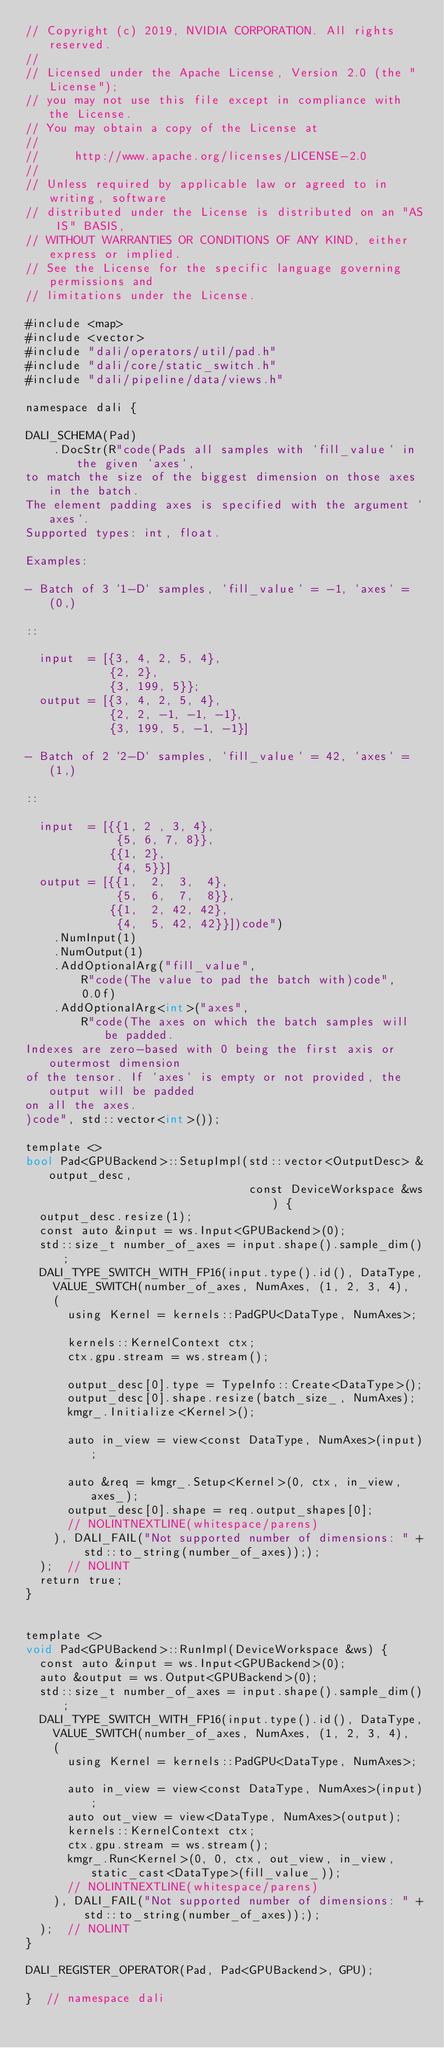<code> <loc_0><loc_0><loc_500><loc_500><_Cuda_>// Copyright (c) 2019, NVIDIA CORPORATION. All rights reserved.
//
// Licensed under the Apache License, Version 2.0 (the "License");
// you may not use this file except in compliance with the License.
// You may obtain a copy of the License at
//
//     http://www.apache.org/licenses/LICENSE-2.0
//
// Unless required by applicable law or agreed to in writing, software
// distributed under the License is distributed on an "AS IS" BASIS,
// WITHOUT WARRANTIES OR CONDITIONS OF ANY KIND, either express or implied.
// See the License for the specific language governing permissions and
// limitations under the License.

#include <map>
#include <vector>
#include "dali/operators/util/pad.h"
#include "dali/core/static_switch.h"
#include "dali/pipeline/data/views.h"

namespace dali {

DALI_SCHEMA(Pad)
    .DocStr(R"code(Pads all samples with `fill_value` in the given `axes`,
to match the size of the biggest dimension on those axes in the batch.
The element padding axes is specified with the argument `axes`.
Supported types: int, float.

Examples:

- Batch of 3 `1-D` samples, `fill_value` = -1, `axes` = (0,)

::

  input  = [{3, 4, 2, 5, 4},
            {2, 2},
            {3, 199, 5}};
  output = [{3, 4, 2, 5, 4},
            {2, 2, -1, -1, -1},
            {3, 199, 5, -1, -1}]

- Batch of 2 `2-D` samples, `fill_value` = 42, `axes` = (1,)

::

  input  = [{{1, 2 , 3, 4},
             {5, 6, 7, 8}},
            {{1, 2},
             {4, 5}}]
  output = [{{1,  2,  3,  4},
             {5,  6,  7,  8}},
            {{1,  2, 42, 42},
             {4,  5, 42, 42}}])code")
    .NumInput(1)
    .NumOutput(1)
    .AddOptionalArg("fill_value",
        R"code(The value to pad the batch with)code",
        0.0f)
    .AddOptionalArg<int>("axes",
        R"code(The axes on which the batch samples will be padded.
Indexes are zero-based with 0 being the first axis or outermost dimension
of the tensor. If `axes` is empty or not provided, the output will be padded
on all the axes.
)code", std::vector<int>());

template <>
bool Pad<GPUBackend>::SetupImpl(std::vector<OutputDesc> &output_desc,
                                const DeviceWorkspace &ws) {
  output_desc.resize(1);
  const auto &input = ws.Input<GPUBackend>(0);
  std::size_t number_of_axes = input.shape().sample_dim();
  DALI_TYPE_SWITCH_WITH_FP16(input.type().id(), DataType,
    VALUE_SWITCH(number_of_axes, NumAxes, (1, 2, 3, 4),
    (
      using Kernel = kernels::PadGPU<DataType, NumAxes>;

      kernels::KernelContext ctx;
      ctx.gpu.stream = ws.stream();

      output_desc[0].type = TypeInfo::Create<DataType>();
      output_desc[0].shape.resize(batch_size_, NumAxes);
      kmgr_.Initialize<Kernel>();

      auto in_view = view<const DataType, NumAxes>(input);

      auto &req = kmgr_.Setup<Kernel>(0, ctx, in_view, axes_);
      output_desc[0].shape = req.output_shapes[0];
      // NOLINTNEXTLINE(whitespace/parens)
    ), DALI_FAIL("Not supported number of dimensions: " + std::to_string(number_of_axes)););
  );  // NOLINT
  return true;
}


template <>
void Pad<GPUBackend>::RunImpl(DeviceWorkspace &ws) {
  const auto &input = ws.Input<GPUBackend>(0);
  auto &output = ws.Output<GPUBackend>(0);
  std::size_t number_of_axes = input.shape().sample_dim();
  DALI_TYPE_SWITCH_WITH_FP16(input.type().id(), DataType,
    VALUE_SWITCH(number_of_axes, NumAxes, (1, 2, 3, 4),
    (
      using Kernel = kernels::PadGPU<DataType, NumAxes>;

      auto in_view = view<const DataType, NumAxes>(input);
      auto out_view = view<DataType, NumAxes>(output);
      kernels::KernelContext ctx;
      ctx.gpu.stream = ws.stream();
      kmgr_.Run<Kernel>(0, 0, ctx, out_view, in_view, static_cast<DataType>(fill_value_));
      // NOLINTNEXTLINE(whitespace/parens)
    ), DALI_FAIL("Not supported number of dimensions: " + std::to_string(number_of_axes)););
  );  // NOLINT
}

DALI_REGISTER_OPERATOR(Pad, Pad<GPUBackend>, GPU);

}  // namespace dali
</code> 